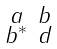Convert formula to latex. <formula><loc_0><loc_0><loc_500><loc_500>\begin{smallmatrix} a & b \\ b ^ { * } & d \end{smallmatrix}</formula> 